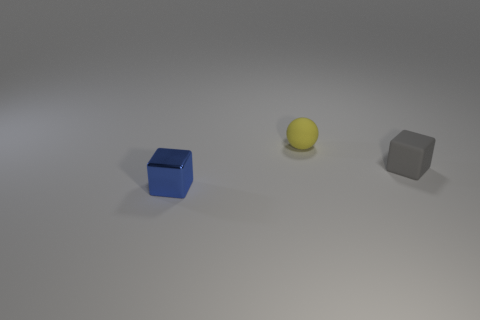What number of small red cubes are the same material as the tiny yellow ball?
Offer a terse response. 0. There is a yellow object; is its size the same as the rubber object that is in front of the yellow thing?
Offer a very short reply. Yes. The tiny thing that is both right of the tiny metallic thing and in front of the small yellow matte object is what color?
Provide a short and direct response. Gray. There is a tiny matte thing in front of the yellow rubber sphere; are there any tiny gray blocks that are on the right side of it?
Keep it short and to the point. No. Are there an equal number of blue cubes that are to the right of the tiny blue shiny cube and big cyan balls?
Ensure brevity in your answer.  Yes. There is a tiny cube that is in front of the tiny rubber object right of the tiny ball; how many small blocks are in front of it?
Your answer should be compact. 0. Are there any blue cubes of the same size as the yellow matte sphere?
Offer a terse response. Yes. Is the number of cubes behind the yellow sphere less than the number of gray rubber cubes?
Your answer should be compact. Yes. What is the tiny object that is behind the small thing that is right of the tiny rubber thing left of the tiny gray matte object made of?
Ensure brevity in your answer.  Rubber. Is the number of small blue objects that are on the left side of the yellow rubber thing greater than the number of tiny rubber objects in front of the gray cube?
Offer a very short reply. Yes. 